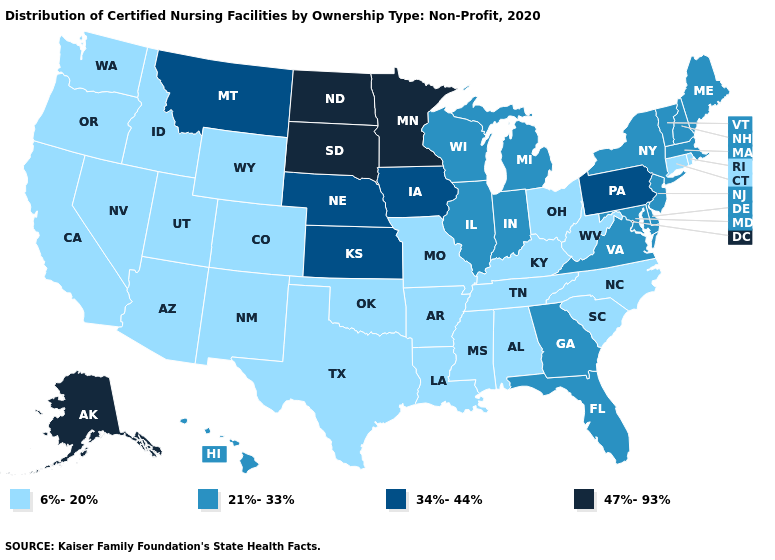Name the states that have a value in the range 21%-33%?
Give a very brief answer. Delaware, Florida, Georgia, Hawaii, Illinois, Indiana, Maine, Maryland, Massachusetts, Michigan, New Hampshire, New Jersey, New York, Vermont, Virginia, Wisconsin. Which states have the lowest value in the West?
Concise answer only. Arizona, California, Colorado, Idaho, Nevada, New Mexico, Oregon, Utah, Washington, Wyoming. What is the value of Idaho?
Give a very brief answer. 6%-20%. Does the map have missing data?
Give a very brief answer. No. Does Alaska have the lowest value in the West?
Give a very brief answer. No. Does the map have missing data?
Short answer required. No. Does Minnesota have the highest value in the USA?
Answer briefly. Yes. What is the highest value in the USA?
Quick response, please. 47%-93%. What is the highest value in the West ?
Quick response, please. 47%-93%. What is the value of Indiana?
Concise answer only. 21%-33%. How many symbols are there in the legend?
Be succinct. 4. Which states have the highest value in the USA?
Answer briefly. Alaska, Minnesota, North Dakota, South Dakota. Name the states that have a value in the range 21%-33%?
Write a very short answer. Delaware, Florida, Georgia, Hawaii, Illinois, Indiana, Maine, Maryland, Massachusetts, Michigan, New Hampshire, New Jersey, New York, Vermont, Virginia, Wisconsin. Does Maryland have the same value as Nebraska?
Concise answer only. No. What is the value of South Carolina?
Write a very short answer. 6%-20%. 